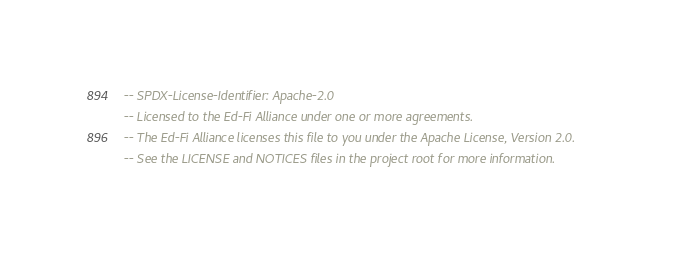Convert code to text. <code><loc_0><loc_0><loc_500><loc_500><_SQL_>-- SPDX-License-Identifier: Apache-2.0
-- Licensed to the Ed-Fi Alliance under one or more agreements.
-- The Ed-Fi Alliance licenses this file to you under the Apache License, Version 2.0.
-- See the LICENSE and NOTICES files in the project root for more information.
</code> 